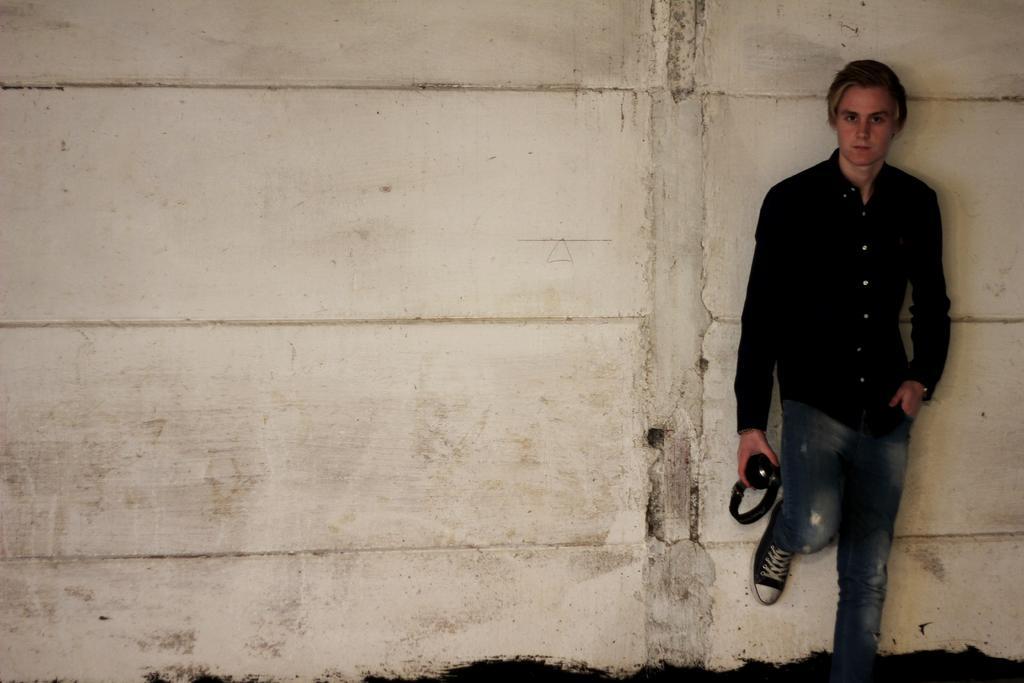Please provide a concise description of this image. In the background there is a wall and we can see a man wearing a black shirt and he is holding a headset in his hand. 